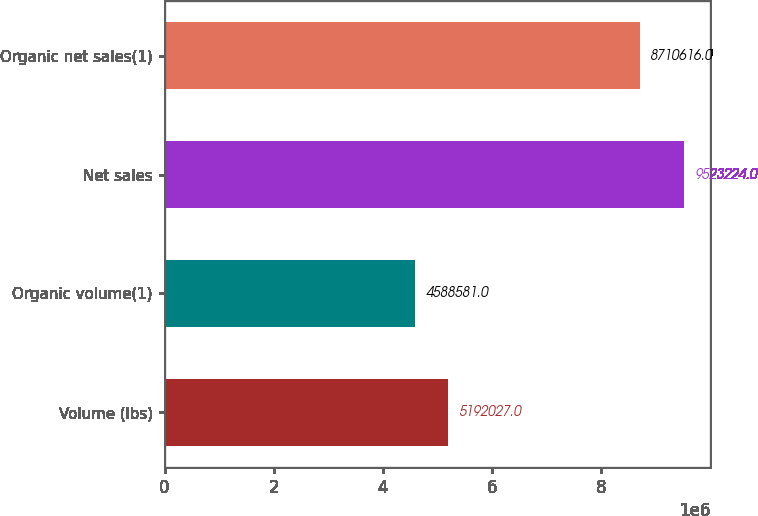Convert chart. <chart><loc_0><loc_0><loc_500><loc_500><bar_chart><fcel>Volume (lbs)<fcel>Organic volume(1)<fcel>Net sales<fcel>Organic net sales(1)<nl><fcel>5.19203e+06<fcel>4.58858e+06<fcel>9.52322e+06<fcel>8.71062e+06<nl></chart> 